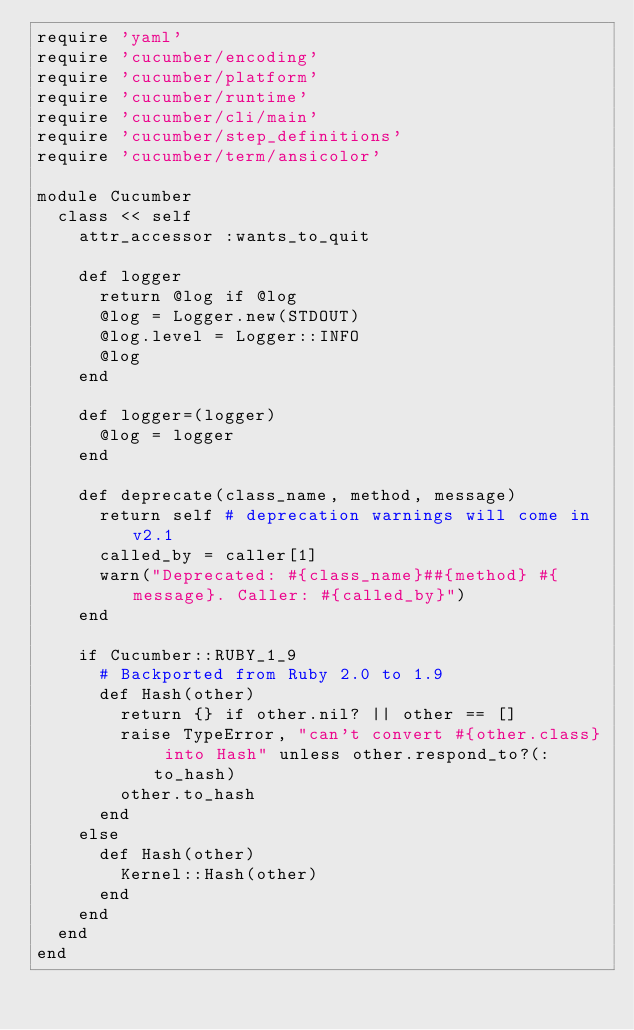<code> <loc_0><loc_0><loc_500><loc_500><_Ruby_>require 'yaml'
require 'cucumber/encoding'
require 'cucumber/platform'
require 'cucumber/runtime'
require 'cucumber/cli/main'
require 'cucumber/step_definitions'
require 'cucumber/term/ansicolor'

module Cucumber
  class << self
    attr_accessor :wants_to_quit

    def logger
      return @log if @log
      @log = Logger.new(STDOUT)
      @log.level = Logger::INFO
      @log
    end

    def logger=(logger)
      @log = logger
    end

    def deprecate(class_name, method, message)
      return self # deprecation warnings will come in v2.1
      called_by = caller[1]
      warn("Deprecated: #{class_name}##{method} #{message}. Caller: #{called_by}")
    end

    if Cucumber::RUBY_1_9
      # Backported from Ruby 2.0 to 1.9
      def Hash(other)
        return {} if other.nil? || other == []
        raise TypeError, "can't convert #{other.class} into Hash" unless other.respond_to?(:to_hash)
        other.to_hash
      end
    else
      def Hash(other)
        Kernel::Hash(other)
      end
    end
  end
end
</code> 